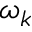<formula> <loc_0><loc_0><loc_500><loc_500>\omega _ { k }</formula> 